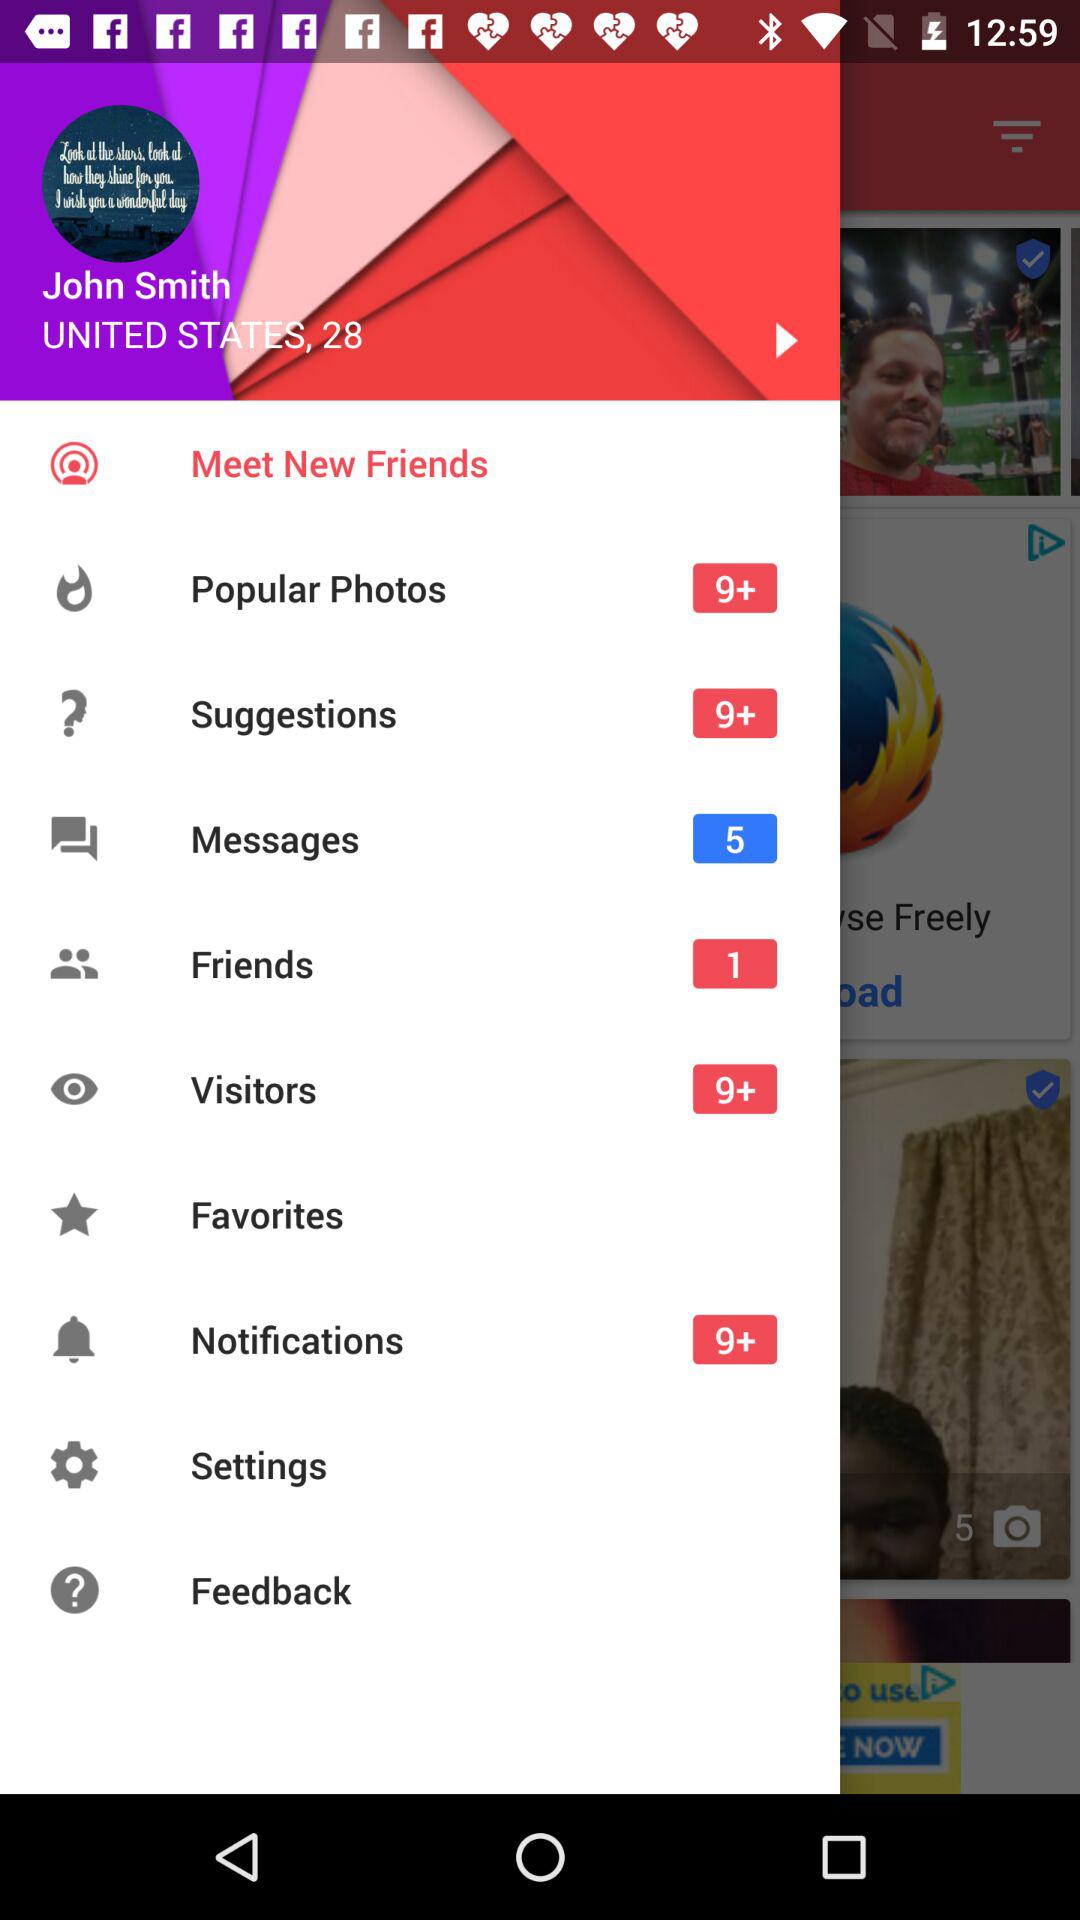What's the number of visitors notification? The number of visitors notification is 9+. 